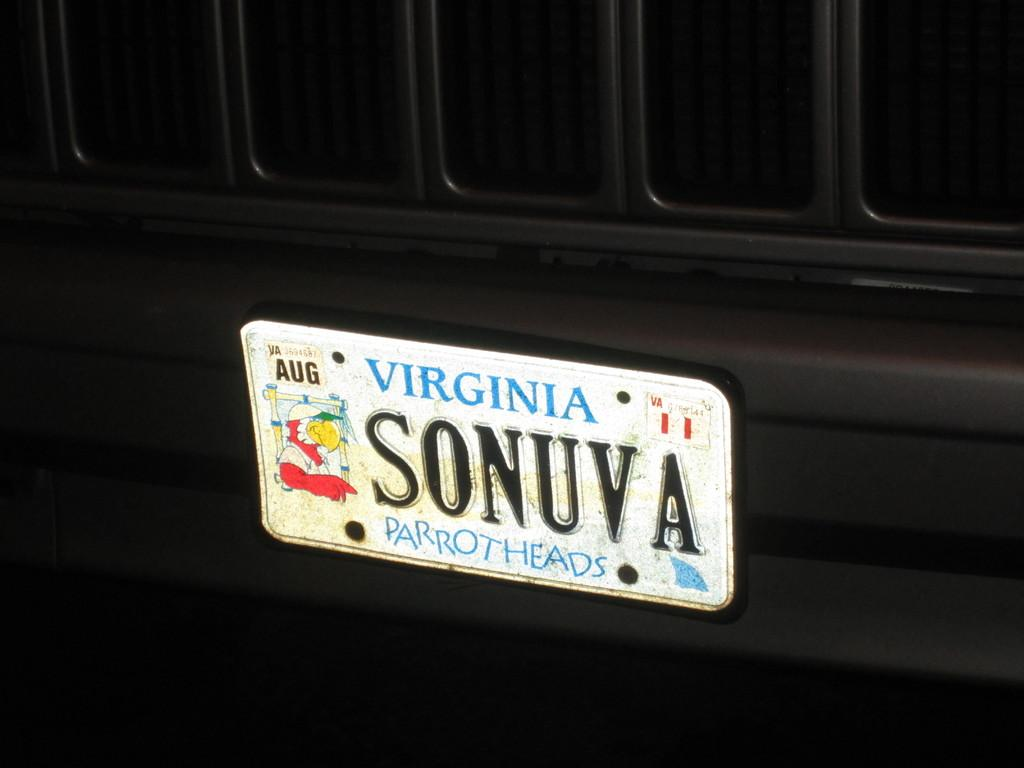What is the main object in the image? There is a name board in the image. Where is the name board located? The name board is on a surface. What type of vegetable is being prepared in the image? There is no vegetable or any indication of food preparation in the image; it only features a name board on a surface. 